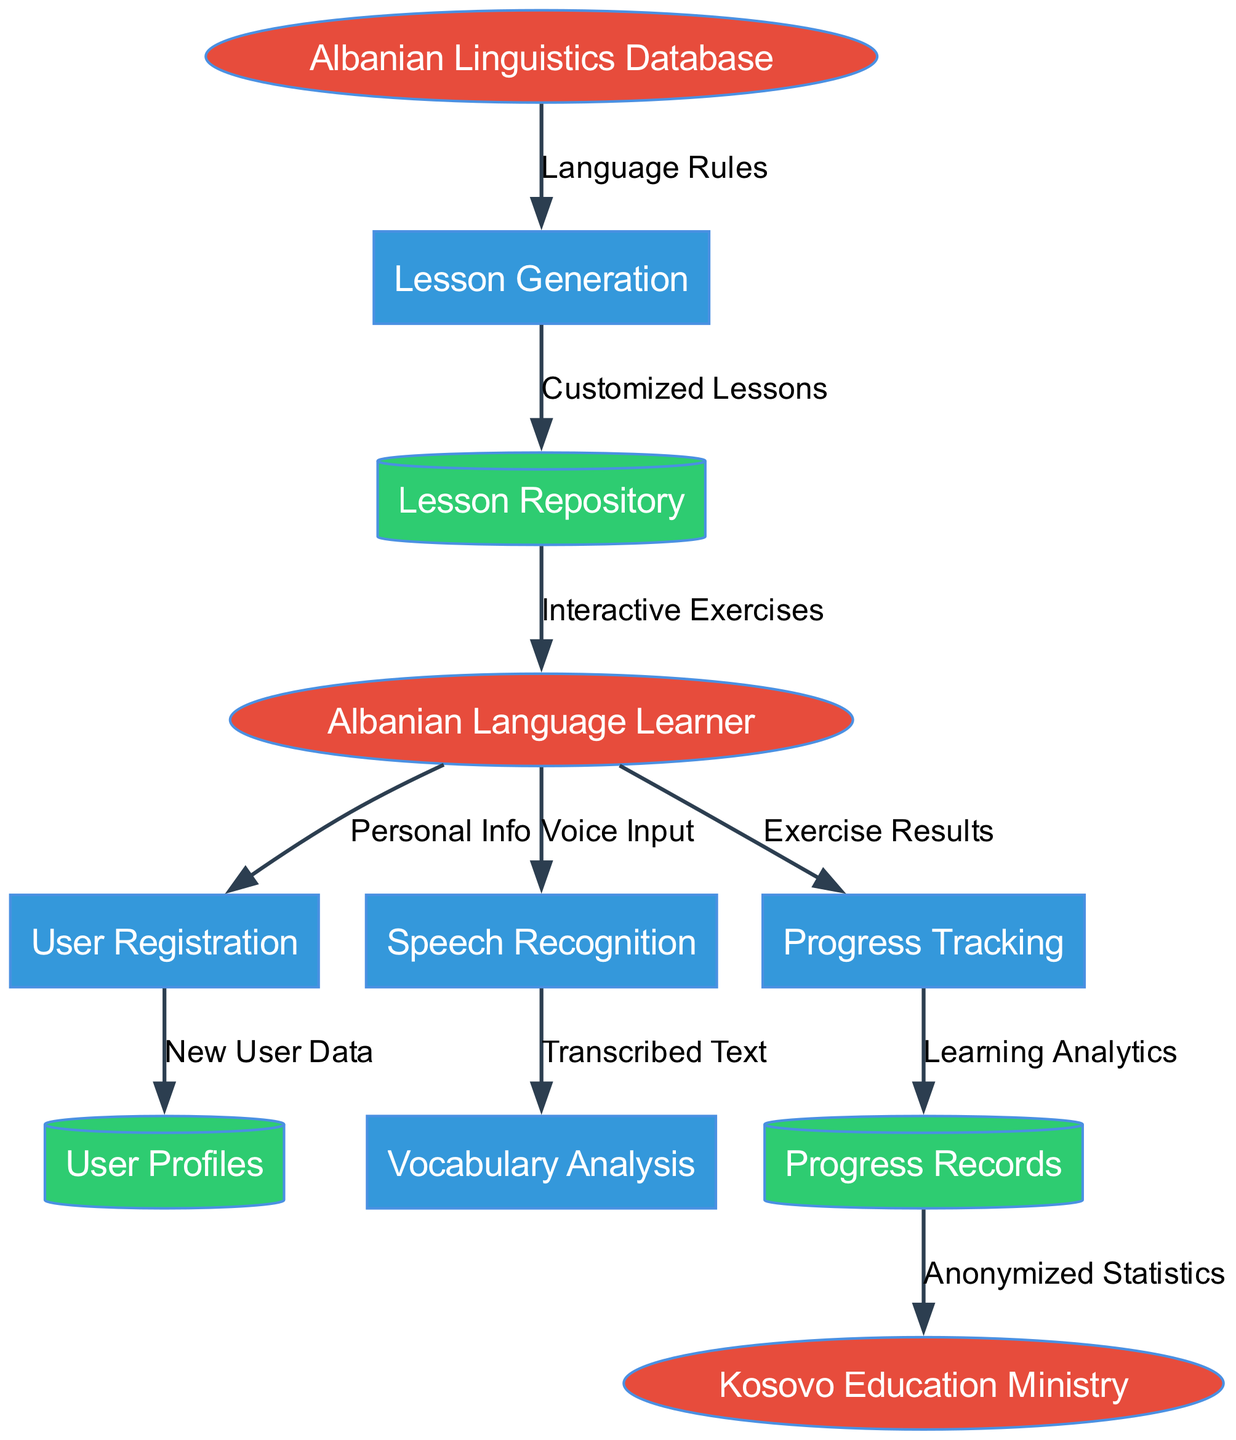What are the external entities in this diagram? The diagram shows three external entities: "Albanian Language Learner," "Albanian Linguistics Database," and "Kosovo Education Ministry." These are labeled as ellipses in the diagram.
Answer: Albanian Language Learner, Albanian Linguistics Database, Kosovo Education Ministry How many processes are represented in the diagram? The diagram contains five processes, which are represented as rectangles. The processes are "User Registration," "Lesson Generation," "Speech Recognition," "Progress Tracking," and "Vocabulary Analysis."
Answer: 5 What is the flow of data from 'User Registration' to a data store? The data flow from 'User Registration' leads to the 'User Profiles' data store with the label "New User Data," indicating that the information collected from the user registration process is stored in user profiles.
Answer: User Profiles Which process receives 'Voice Input' from the external entity? The 'Speech Recognition' process receives 'Voice Input' from the 'Albanian Language Learner,' which is indicated by the directed flow leading into this process.
Answer: Speech Recognition What kind of data does 'Progress Tracking' send to 'Progress Records'? 'Progress Tracking' sends 'Learning Analytics' to 'Progress Records,' showing that it is responsible for analyzing and recording learner progress data.
Answer: Learning Analytics How does 'Lesson Generation' receive input, and from where? 'Lesson Generation' receives 'Language Rules' from the 'Albanian Linguistics Database.' This input guides the creation of customized lessons for the learner, as indicated by the flow direction.
Answer: Language Rules What is the final destination of the data flow from 'Progress Records'? The final destination of the data flow coming from 'Progress Records' is the 'Kosovo Education Ministry,' where anonymized statistics are sent for further reporting or analysis.
Answer: Kosovo Education Ministry How many data stores are depicted in the diagram? The diagram includes three data stores shown as cylinders. These stores are 'User Profiles,' 'Lesson Repository,' and 'Progress Records.'
Answer: 3 Which process outputs 'Interactive Exercises' to the user? The 'Lesson Generation' process outputs 'Interactive Exercises' to the 'Albanian Language Learner,' which indicates that the customized lessons created are made accessible to the learner.
Answer: Lesson Generation 